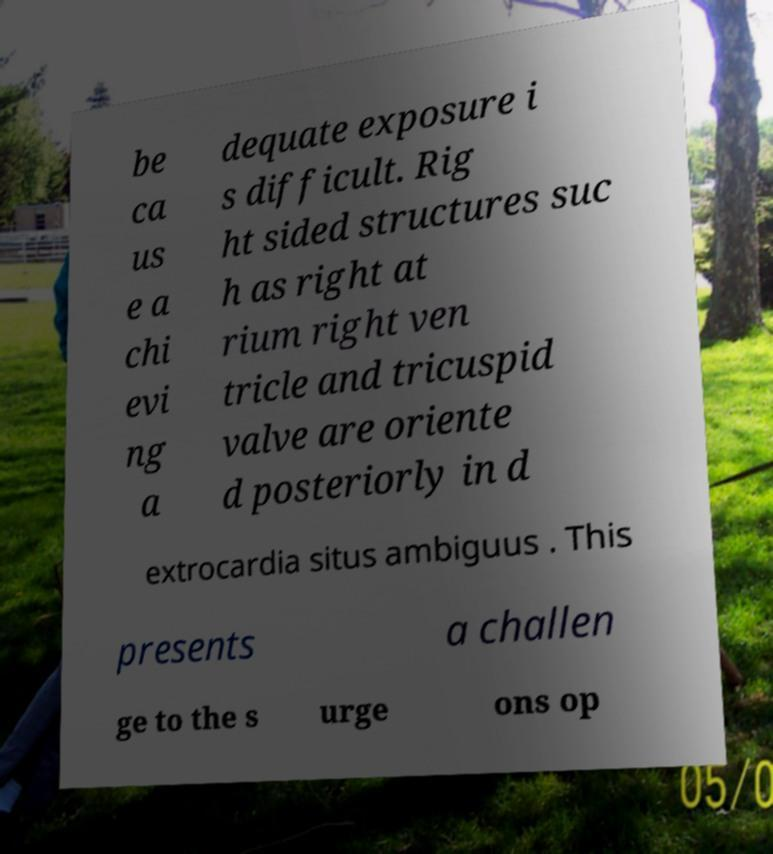I need the written content from this picture converted into text. Can you do that? be ca us e a chi evi ng a dequate exposure i s difficult. Rig ht sided structures suc h as right at rium right ven tricle and tricuspid valve are oriente d posteriorly in d extrocardia situs ambiguus . This presents a challen ge to the s urge ons op 